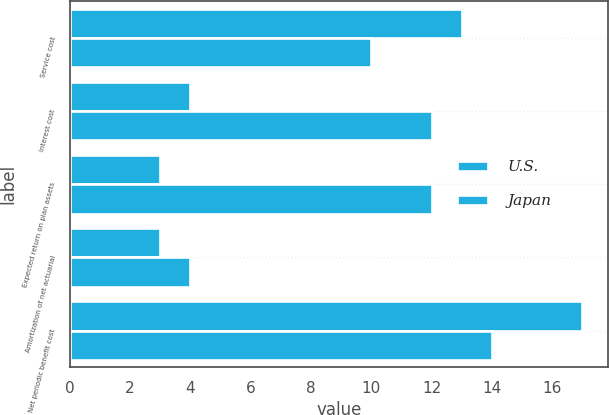<chart> <loc_0><loc_0><loc_500><loc_500><stacked_bar_chart><ecel><fcel>Service cost<fcel>Interest cost<fcel>Expected return on plan assets<fcel>Amortization of net actuarial<fcel>Net periodic benefit cost<nl><fcel>U.S.<fcel>13<fcel>4<fcel>3<fcel>3<fcel>17<nl><fcel>Japan<fcel>10<fcel>12<fcel>12<fcel>4<fcel>14<nl></chart> 